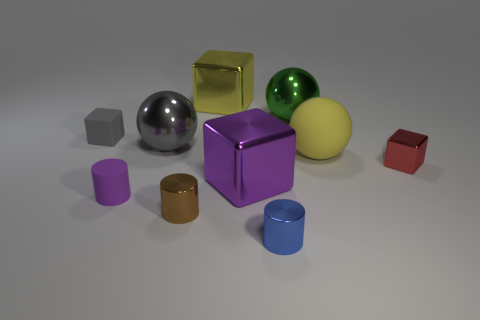There is a yellow thing that is to the right of the large purple metallic object; is its size the same as the purple metallic object on the left side of the small blue shiny cylinder?
Your answer should be compact. Yes. Is the number of small objects that are behind the small shiny block less than the number of big balls that are behind the matte cube?
Provide a succinct answer. No. What material is the big block that is the same color as the matte ball?
Your answer should be very brief. Metal. There is a large cube behind the big purple thing; what color is it?
Make the answer very short. Yellow. Do the matte cube and the tiny metallic block have the same color?
Your answer should be compact. No. There is a big shiny ball that is to the right of the big metallic sphere in front of the tiny gray object; what number of green metal balls are behind it?
Make the answer very short. 0. The red shiny cube is what size?
Keep it short and to the point. Small. There is a gray cube that is the same size as the red cube; what is its material?
Give a very brief answer. Rubber. There is a green metallic thing; what number of big yellow balls are on the right side of it?
Keep it short and to the point. 1. Is the purple object that is right of the small purple rubber thing made of the same material as the tiny cube that is right of the small purple thing?
Offer a terse response. Yes. 